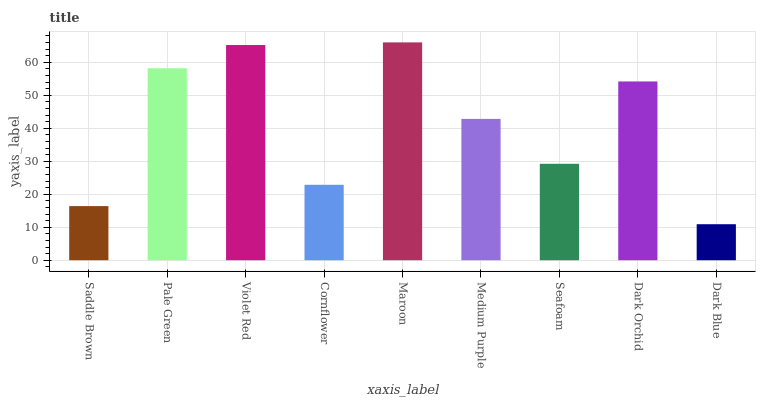Is Dark Blue the minimum?
Answer yes or no. Yes. Is Maroon the maximum?
Answer yes or no. Yes. Is Pale Green the minimum?
Answer yes or no. No. Is Pale Green the maximum?
Answer yes or no. No. Is Pale Green greater than Saddle Brown?
Answer yes or no. Yes. Is Saddle Brown less than Pale Green?
Answer yes or no. Yes. Is Saddle Brown greater than Pale Green?
Answer yes or no. No. Is Pale Green less than Saddle Brown?
Answer yes or no. No. Is Medium Purple the high median?
Answer yes or no. Yes. Is Medium Purple the low median?
Answer yes or no. Yes. Is Dark Blue the high median?
Answer yes or no. No. Is Seafoam the low median?
Answer yes or no. No. 